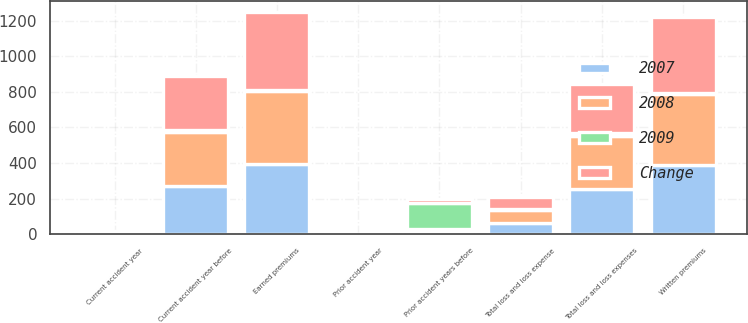<chart> <loc_0><loc_0><loc_500><loc_500><stacked_bar_chart><ecel><fcel>Written premiums<fcel>Earned premiums<fcel>Current accident year before<fcel>Current accident year<fcel>Prior accident years before<fcel>Total loss and loss expenses<fcel>Prior accident year<fcel>Total loss and loss expense<nl><fcel>2007<fcel>388<fcel>394<fcel>273<fcel>3<fcel>20<fcel>256<fcel>0<fcel>64.9<nl><fcel>2008<fcel>402<fcel>411<fcel>303<fcel>2<fcel>8<fcel>297<fcel>0<fcel>72.3<nl><fcel>Change<fcel>429<fcel>440<fcel>303<fcel>1<fcel>25<fcel>278<fcel>0<fcel>63.5<nl><fcel>2009<fcel>3.4<fcel>4.1<fcel>9.9<fcel>12.9<fcel>146.2<fcel>13.9<fcel>0<fcel>7.4<nl></chart> 